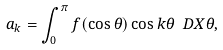Convert formula to latex. <formula><loc_0><loc_0><loc_500><loc_500>a _ { k } = \int _ { 0 } ^ { \pi } f ( \cos \theta ) \cos k \theta \ D X { \theta } ,</formula> 